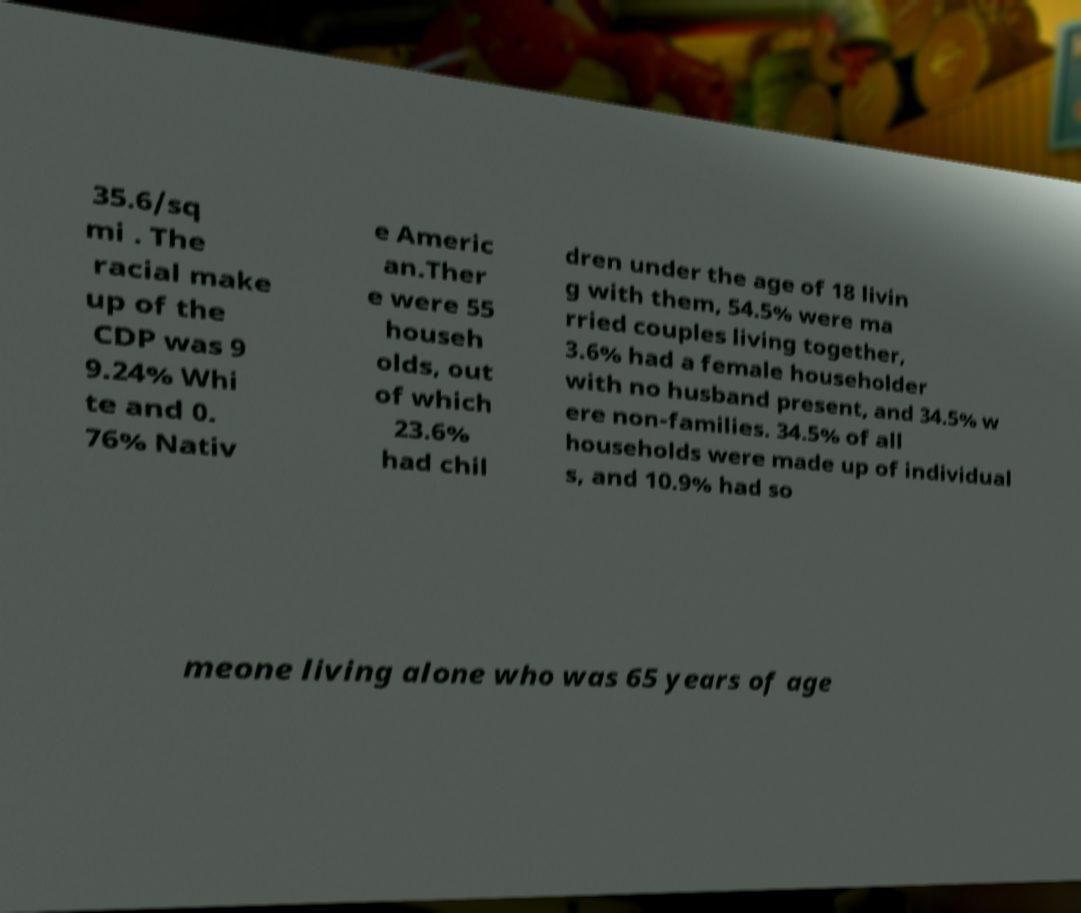Can you read and provide the text displayed in the image?This photo seems to have some interesting text. Can you extract and type it out for me? 35.6/sq mi . The racial make up of the CDP was 9 9.24% Whi te and 0. 76% Nativ e Americ an.Ther e were 55 househ olds, out of which 23.6% had chil dren under the age of 18 livin g with them, 54.5% were ma rried couples living together, 3.6% had a female householder with no husband present, and 34.5% w ere non-families. 34.5% of all households were made up of individual s, and 10.9% had so meone living alone who was 65 years of age 